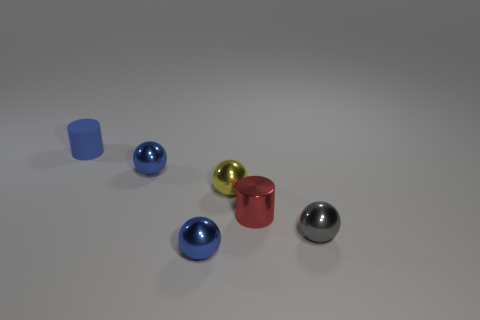Do the metallic cylinder and the tiny metal thing that is in front of the gray ball have the same color?
Your answer should be compact. No. Is the number of tiny red cylinders behind the yellow sphere greater than the number of small gray things?
Provide a succinct answer. No. How many objects are either tiny shiny objects that are left of the tiny red thing or blue objects in front of the blue cylinder?
Provide a succinct answer. 3. There is a cylinder that is the same material as the yellow ball; what size is it?
Make the answer very short. Small. Does the thing in front of the small gray shiny thing have the same shape as the red shiny thing?
Give a very brief answer. No. What number of purple things are either small rubber balls or small things?
Offer a very short reply. 0. How many other things are there of the same shape as the small blue rubber thing?
Offer a very short reply. 1. There is a tiny metal thing that is both behind the tiny gray ball and left of the yellow ball; what shape is it?
Provide a short and direct response. Sphere. Are there any tiny blue balls in front of the gray metallic thing?
Keep it short and to the point. Yes. There is a red object that is the same shape as the blue rubber thing; what is its size?
Provide a short and direct response. Small. 